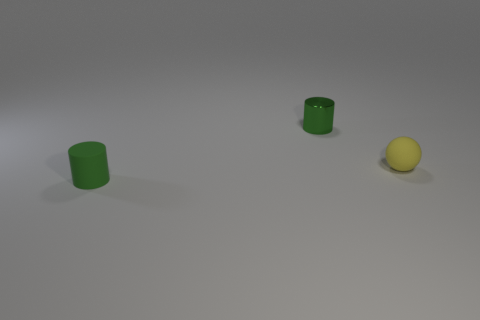There is a object behind the small yellow matte object; is its color the same as the small matte cylinder?
Your response must be concise. Yes. What is the material of the other green cylinder that is the same size as the green metal cylinder?
Your response must be concise. Rubber. There is a tiny cylinder in front of the small green cylinder behind the small sphere; are there any small green metallic cylinders that are in front of it?
Offer a terse response. No. Are there any other things that have the same shape as the tiny yellow thing?
Your answer should be compact. No. Does the small metallic object that is right of the green matte object have the same color as the small rubber object that is left of the tiny green metal thing?
Your response must be concise. Yes. Are any small brown rubber balls visible?
Your response must be concise. No. What is the material of the thing that is the same color as the shiny cylinder?
Make the answer very short. Rubber. There is a cylinder that is on the right side of the tiny cylinder on the left side of the small cylinder that is behind the small matte ball; what is its size?
Your answer should be compact. Small. There is a yellow matte thing; does it have the same shape as the tiny green object that is in front of the sphere?
Make the answer very short. No. Are there any other cylinders that have the same color as the tiny rubber cylinder?
Give a very brief answer. Yes. 